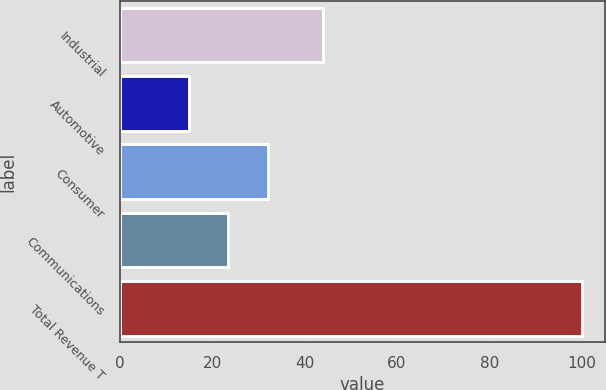Convert chart. <chart><loc_0><loc_0><loc_500><loc_500><bar_chart><fcel>Industrial<fcel>Automotive<fcel>Consumer<fcel>Communications<fcel>Total Revenue T<nl><fcel>44<fcel>15<fcel>32<fcel>23.5<fcel>100<nl></chart> 